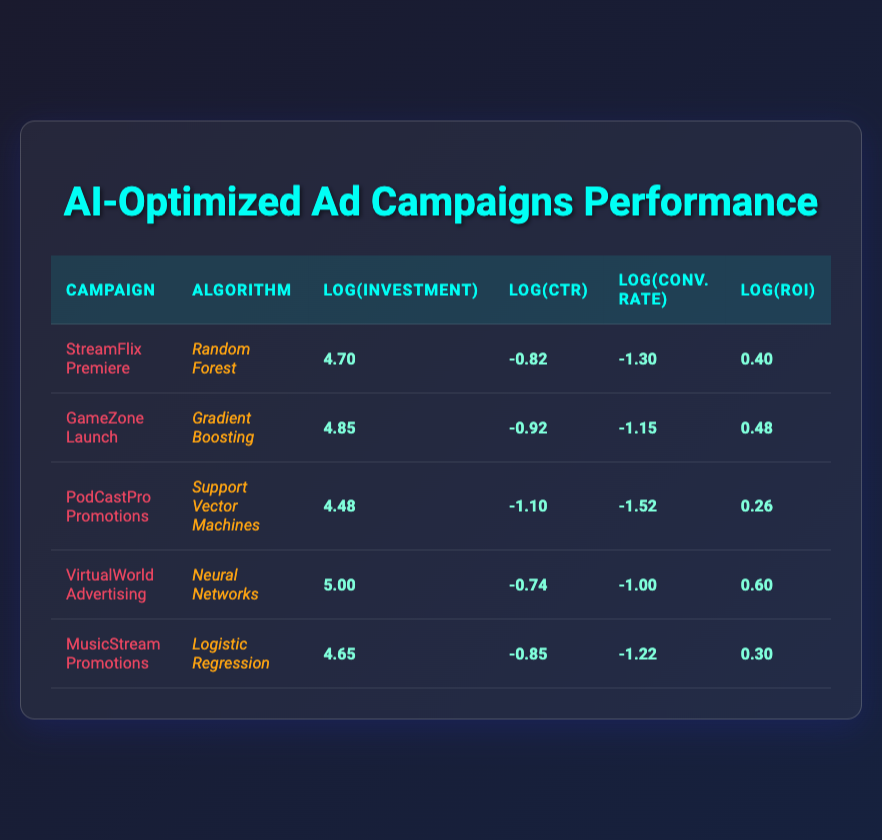What is the click-through rate (CTR) for the GameZone Launch campaign? The CTR for the GameZone Launch campaign is listed directly in the table under the CTR column. It shows a value of 0.12.
Answer: 0.12 Which campaign has the highest return on investment (ROI)? In the table, the ROI values are compared across all campaigns. The campaign with the highest ROI is VirtualWorld Advertising, which has an ROI of 4.0.
Answer: VirtualWorld Advertising What is the log value of the initial investment for MusicStream Promotions? The table shows that the log value of the initial investment for MusicStream Promotions is 4.65, which directly corresponds to its investment of 45000.
Answer: 4.65 Calculate the average log value of the click-through rates (CTR) across all campaigns. The CTR log values from the table are: -0.82, -0.92, -1.10, -0.74, and -0.85. First, sum these values: (-0.82 + -0.92 + -1.10 + -0.74 + -0.85) = -4.43. Then, divide by the number of campaigns (5): -4.43 / 5 = -0.886.
Answer: -0.886 Is the conversion rate for the PodCastPro Promotions campaign higher than that of MusicStream Promotions? The conversion rate for PodCastPro Promotions is 0.03 and for MusicStream Promotions, it is 0.06. Since 0.03 is less than 0.06, the answer is no.
Answer: No What is the difference in log values of the return on investment (ROI) between the highest and lowest campaigns? The log ROI values are: 0.60 for VirtualWorld Advertising (highest) and 0.26 for PodCastPro Promotions (lowest). Thus, the difference is 0.60 - 0.26 = 0.34.
Answer: 0.34 Does the StreamFlix Premiere campaign have a higher initial investment than the PodCastPro Promotions campaign? The initial investment for StreamFlix Premiere is 50000 and for PodCastPro Promotions, it is 30000. Since 50000 is greater than 30000, the answer is yes.
Answer: Yes Which algorithm used had the lowest log value for conversion rate? Looking at the log values for conversion rates, PodCastPro Promotions has the lowest value of -1.52, which represents the performance of the Support Vector Machines algorithm.
Answer: Support Vector Machines 